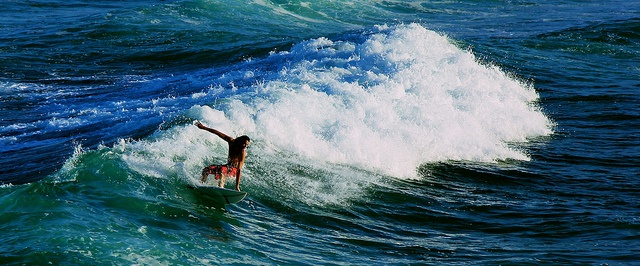Describe the objects in this image and their specific colors. I can see people in blue, black, maroon, gray, and darkgray tones and surfboard in blue, black, teal, and darkgreen tones in this image. 